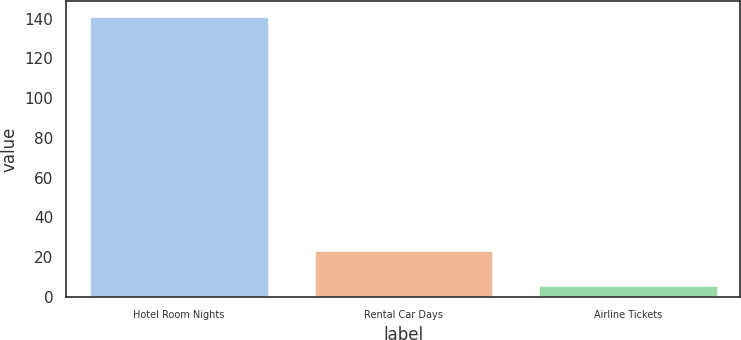Convert chart. <chart><loc_0><loc_0><loc_500><loc_500><bar_chart><fcel>Hotel Room Nights<fcel>Rental Car Days<fcel>Airline Tickets<nl><fcel>141.6<fcel>23.8<fcel>6.2<nl></chart> 